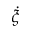<formula> <loc_0><loc_0><loc_500><loc_500>\dot { \xi }</formula> 